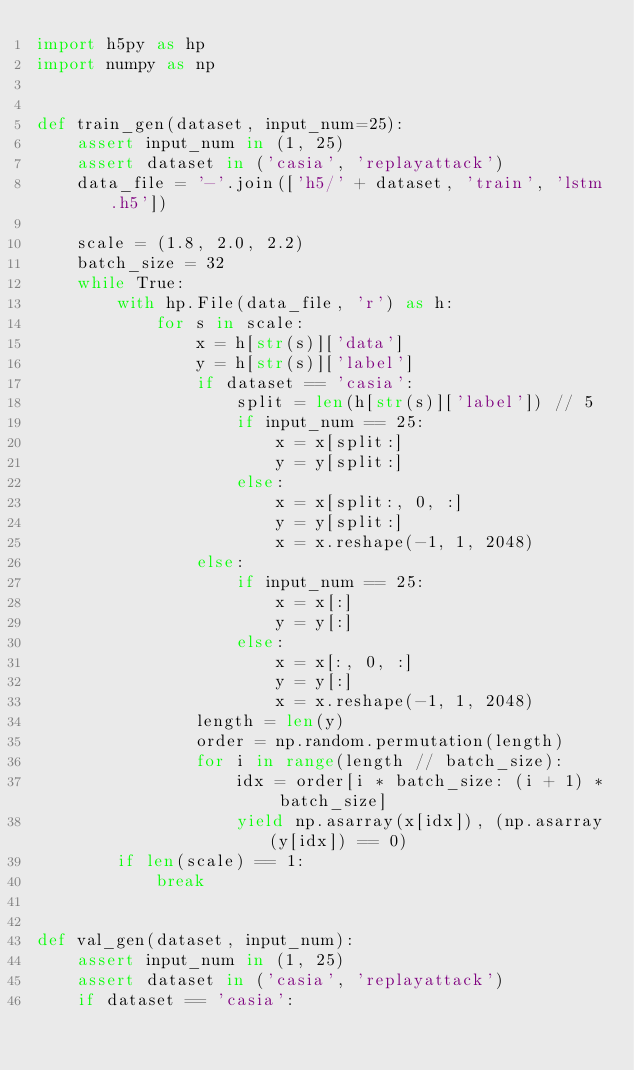<code> <loc_0><loc_0><loc_500><loc_500><_Python_>import h5py as hp
import numpy as np


def train_gen(dataset, input_num=25):
    assert input_num in (1, 25)
    assert dataset in ('casia', 'replayattack')
    data_file = '-'.join(['h5/' + dataset, 'train', 'lstm.h5'])

    scale = (1.8, 2.0, 2.2)
    batch_size = 32
    while True:
        with hp.File(data_file, 'r') as h:
            for s in scale:
                x = h[str(s)]['data']
                y = h[str(s)]['label']
                if dataset == 'casia':
                    split = len(h[str(s)]['label']) // 5
                    if input_num == 25:
                        x = x[split:]
                        y = y[split:]
                    else:
                        x = x[split:, 0, :]
                        y = y[split:]
                        x = x.reshape(-1, 1, 2048)
                else:
                    if input_num == 25:
                        x = x[:]
                        y = y[:]
                    else:
                        x = x[:, 0, :]
                        y = y[:]
                        x = x.reshape(-1, 1, 2048)
                length = len(y)
                order = np.random.permutation(length)
                for i in range(length // batch_size):
                    idx = order[i * batch_size: (i + 1) * batch_size]
                    yield np.asarray(x[idx]), (np.asarray(y[idx]) == 0)
        if len(scale) == 1:
            break


def val_gen(dataset, input_num):
    assert input_num in (1, 25)
    assert dataset in ('casia', 'replayattack')
    if dataset == 'casia':</code> 